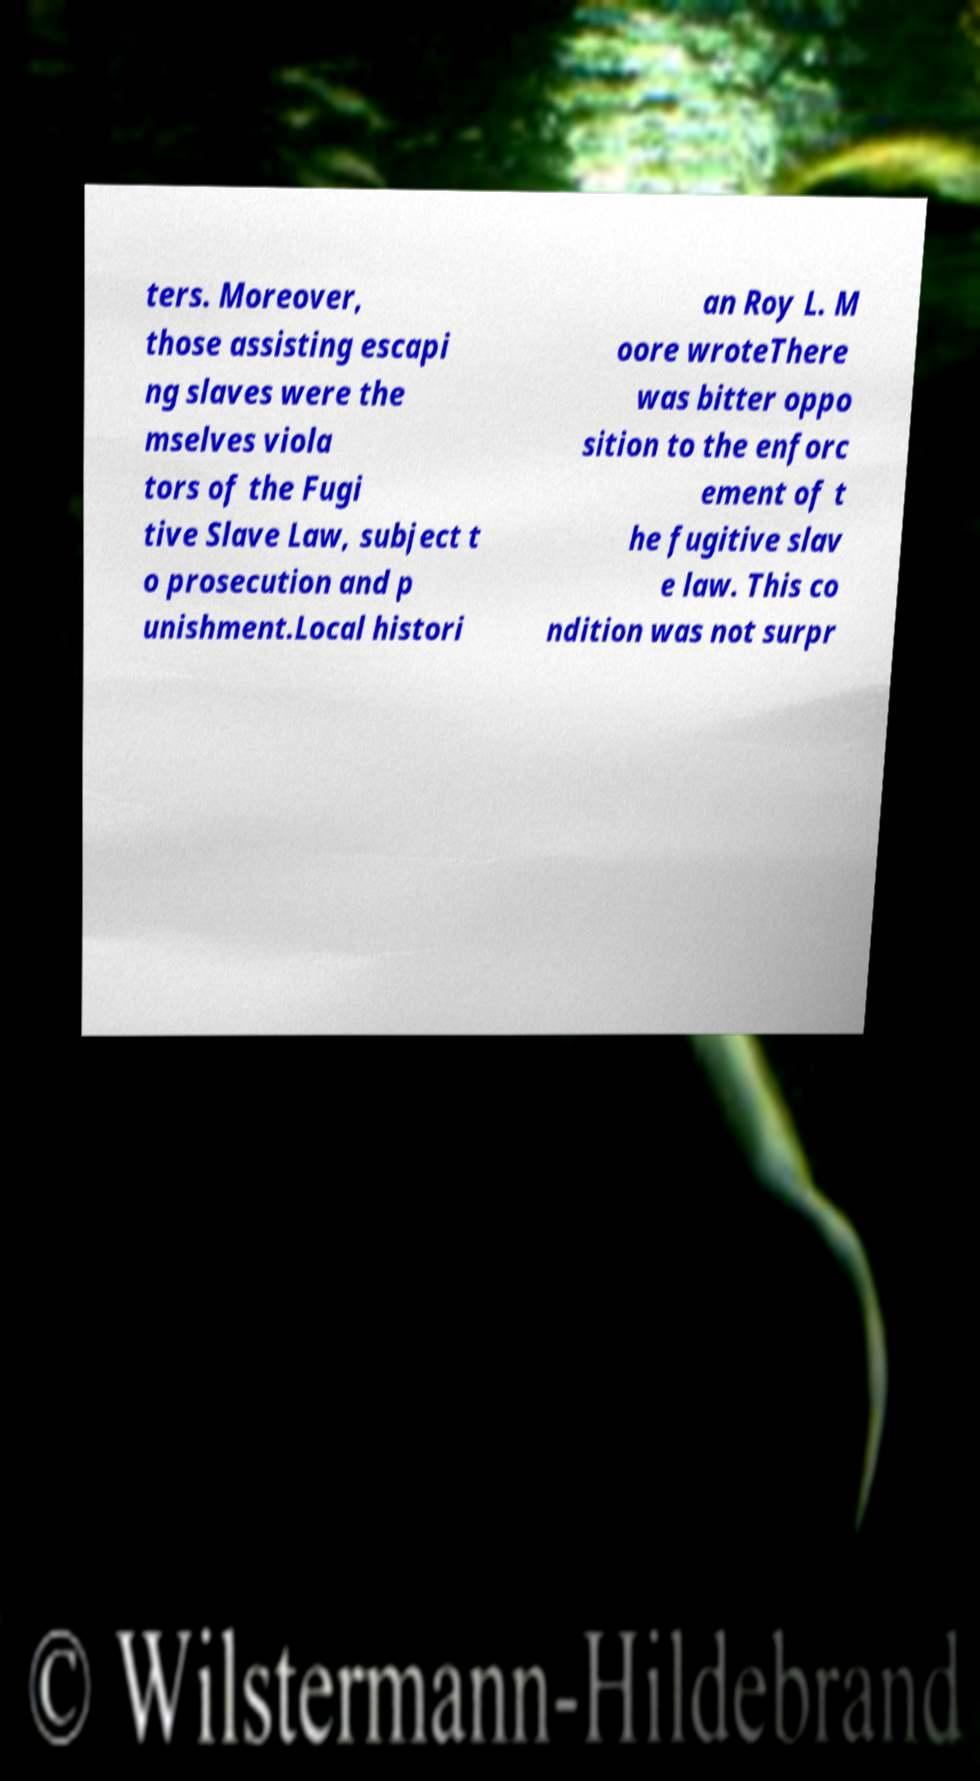Could you extract and type out the text from this image? ters. Moreover, those assisting escapi ng slaves were the mselves viola tors of the Fugi tive Slave Law, subject t o prosecution and p unishment.Local histori an Roy L. M oore wroteThere was bitter oppo sition to the enforc ement of t he fugitive slav e law. This co ndition was not surpr 